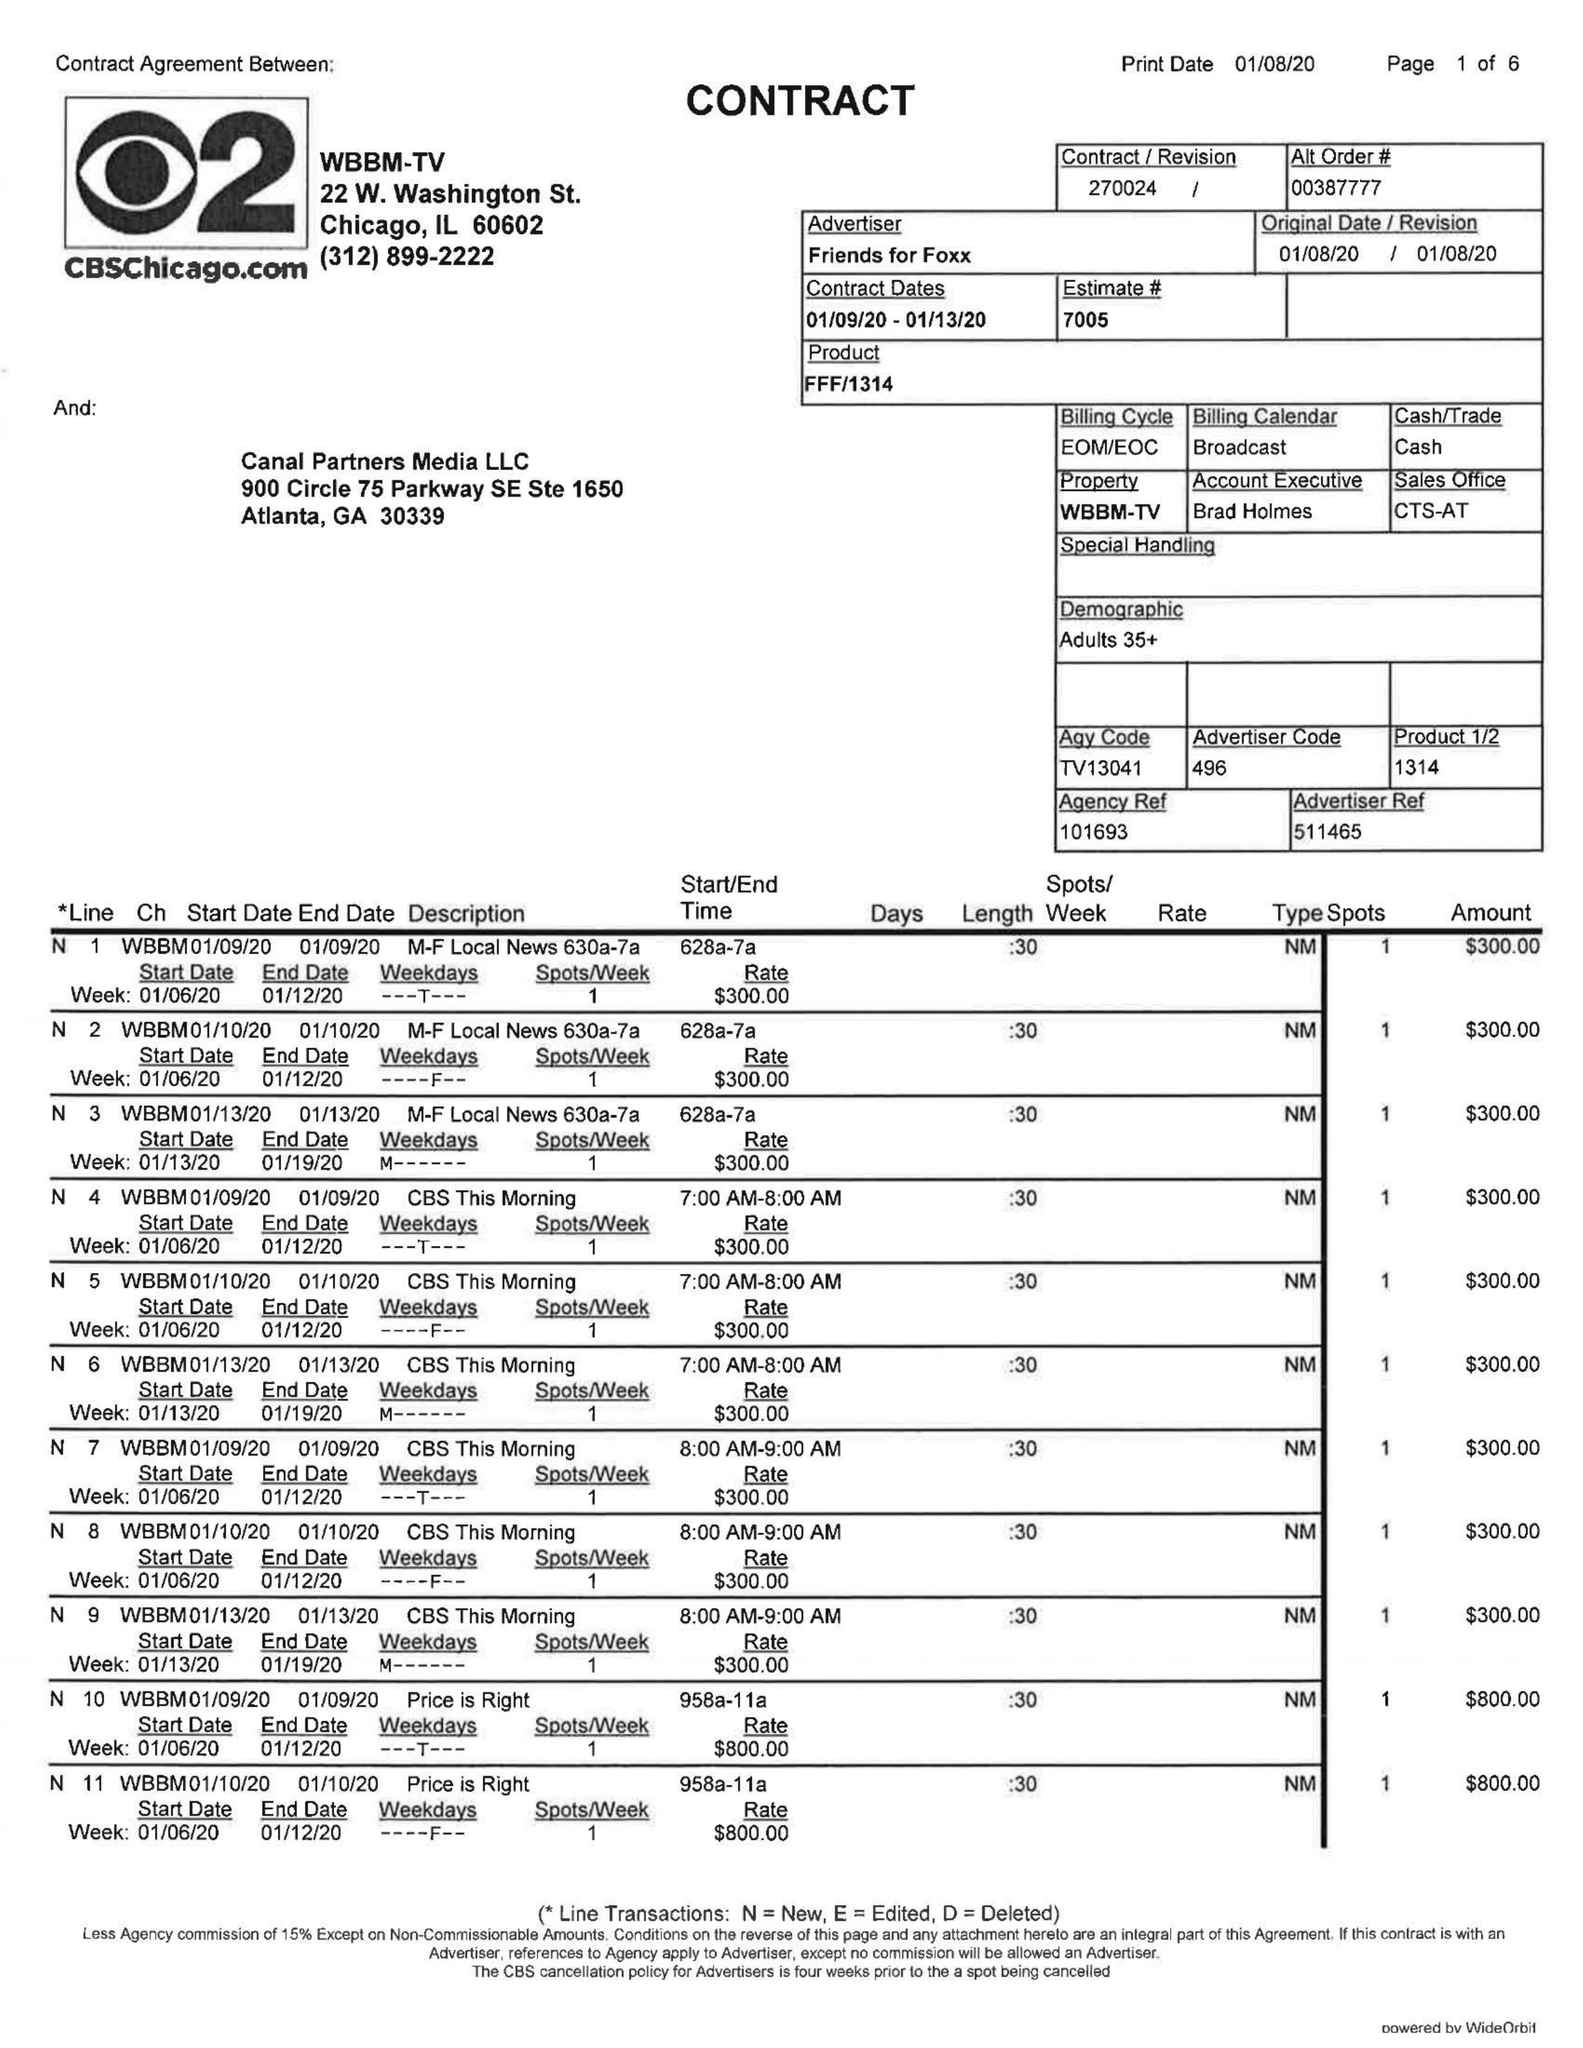What is the value for the flight_to?
Answer the question using a single word or phrase. 01/13/20 